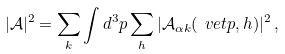Convert formula to latex. <formula><loc_0><loc_0><loc_500><loc_500>| \mathcal { A } | ^ { 2 } = \sum _ { k } \int d ^ { 3 } p \sum _ { h } | \mathcal { A } _ { \alpha k } ( \ v e t { p } , h ) | ^ { 2 } \, ,</formula> 